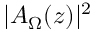<formula> <loc_0><loc_0><loc_500><loc_500>| A _ { \Omega } ( z ) | ^ { 2 }</formula> 